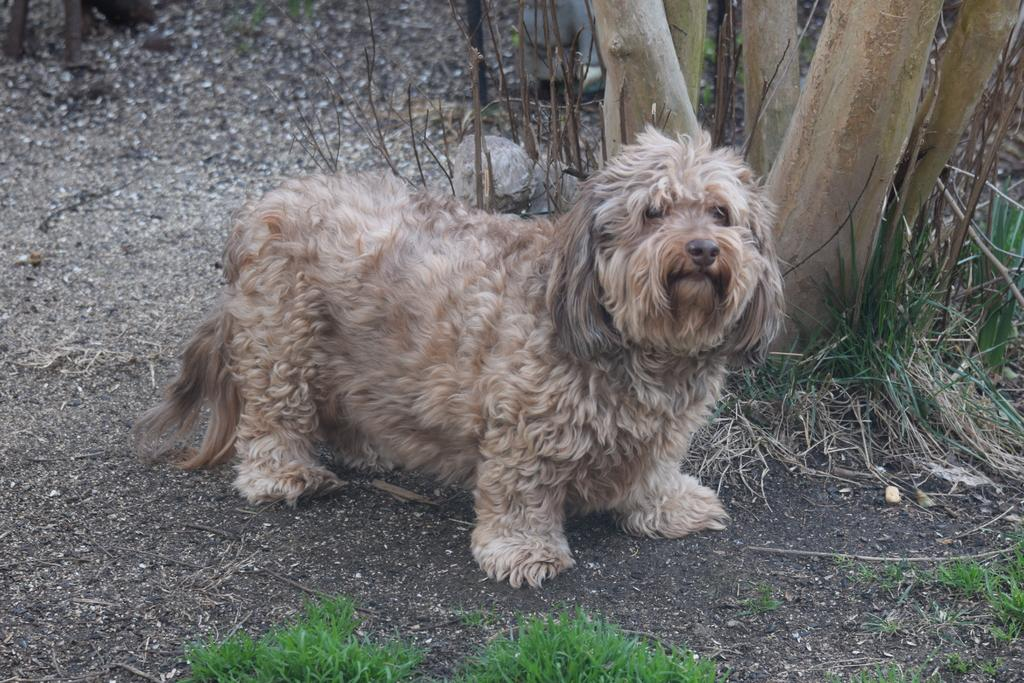What type of animal is in the image? There is a cream-colored dog in the image. What is the dog doing in the image? The dog is standing. What type of terrain is visible in the image? There is grass visible in the image. What else can be seen in the image besides the dog and grass? Tree trunks are present in the image. What type of jeans is the dog wearing in the image? Dogs do not wear jeans, so this detail cannot be found in the image. What type of exchange is happening between the dog and the tree trunks in the image? There is no exchange happening between the dog and the tree trunks in the image; the dog is simply standing near them. 